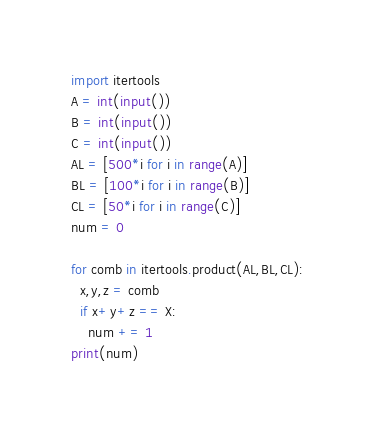Convert code to text. <code><loc_0><loc_0><loc_500><loc_500><_Python_>import itertools
A = int(input())
B = int(input())
C = int(input())
AL = [500*i for i in range(A)]
BL = [100*i for i in range(B)]
CL = [50*i for i in range(C)]
num = 0

for comb in itertools.product(AL,BL,CL):
  x,y,z = comb
  if x+y+z == X:
    num += 1
print(num)</code> 